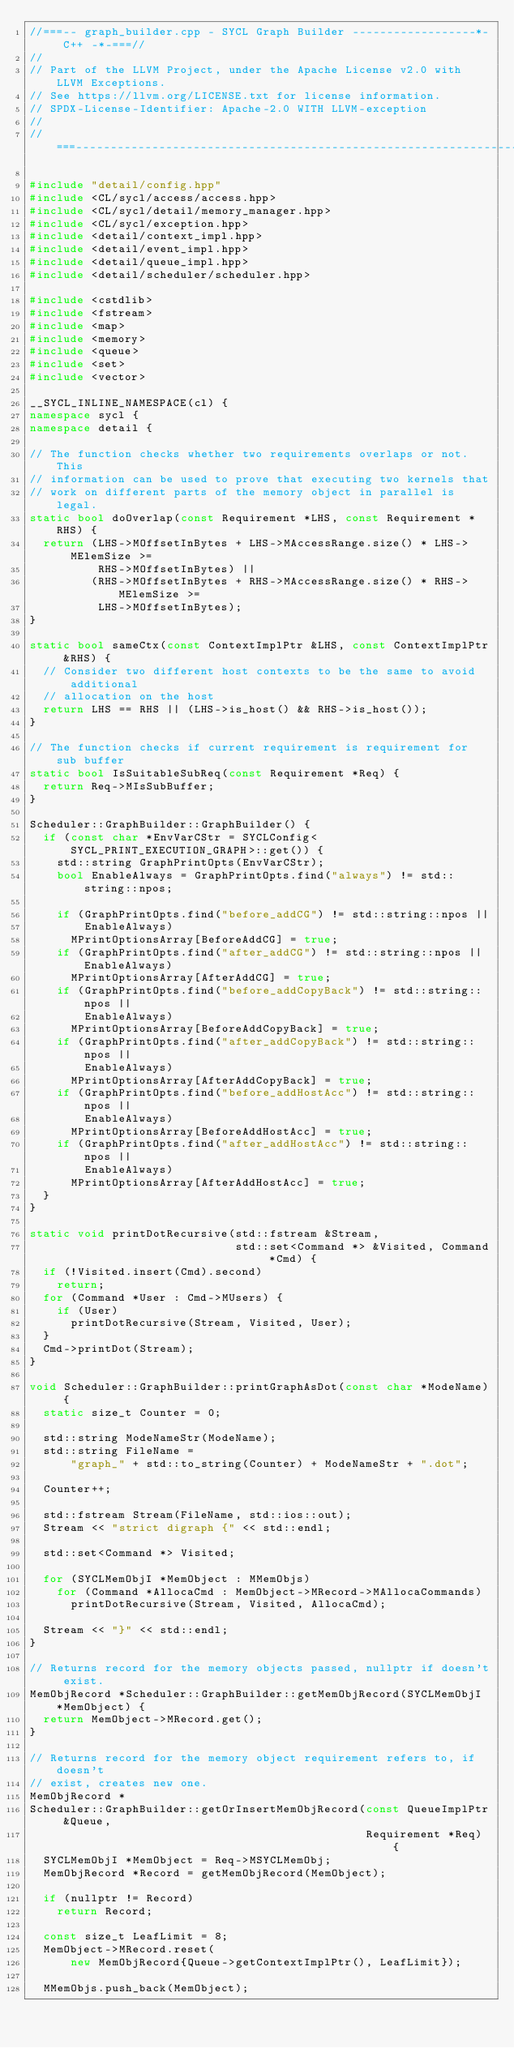<code> <loc_0><loc_0><loc_500><loc_500><_C++_>//===-- graph_builder.cpp - SYCL Graph Builder ------------------*- C++ -*-===//
//
// Part of the LLVM Project, under the Apache License v2.0 with LLVM Exceptions.
// See https://llvm.org/LICENSE.txt for license information.
// SPDX-License-Identifier: Apache-2.0 WITH LLVM-exception
//
//===----------------------------------------------------------------------===//

#include "detail/config.hpp"
#include <CL/sycl/access/access.hpp>
#include <CL/sycl/detail/memory_manager.hpp>
#include <CL/sycl/exception.hpp>
#include <detail/context_impl.hpp>
#include <detail/event_impl.hpp>
#include <detail/queue_impl.hpp>
#include <detail/scheduler/scheduler.hpp>

#include <cstdlib>
#include <fstream>
#include <map>
#include <memory>
#include <queue>
#include <set>
#include <vector>

__SYCL_INLINE_NAMESPACE(cl) {
namespace sycl {
namespace detail {

// The function checks whether two requirements overlaps or not. This
// information can be used to prove that executing two kernels that
// work on different parts of the memory object in parallel is legal.
static bool doOverlap(const Requirement *LHS, const Requirement *RHS) {
  return (LHS->MOffsetInBytes + LHS->MAccessRange.size() * LHS->MElemSize >=
          RHS->MOffsetInBytes) ||
         (RHS->MOffsetInBytes + RHS->MAccessRange.size() * RHS->MElemSize >=
          LHS->MOffsetInBytes);
}

static bool sameCtx(const ContextImplPtr &LHS, const ContextImplPtr &RHS) {
  // Consider two different host contexts to be the same to avoid additional
  // allocation on the host
  return LHS == RHS || (LHS->is_host() && RHS->is_host());
}

// The function checks if current requirement is requirement for sub buffer
static bool IsSuitableSubReq(const Requirement *Req) {
  return Req->MIsSubBuffer;
}

Scheduler::GraphBuilder::GraphBuilder() {
  if (const char *EnvVarCStr = SYCLConfig<SYCL_PRINT_EXECUTION_GRAPH>::get()) {
    std::string GraphPrintOpts(EnvVarCStr);
    bool EnableAlways = GraphPrintOpts.find("always") != std::string::npos;

    if (GraphPrintOpts.find("before_addCG") != std::string::npos ||
        EnableAlways)
      MPrintOptionsArray[BeforeAddCG] = true;
    if (GraphPrintOpts.find("after_addCG") != std::string::npos || EnableAlways)
      MPrintOptionsArray[AfterAddCG] = true;
    if (GraphPrintOpts.find("before_addCopyBack") != std::string::npos ||
        EnableAlways)
      MPrintOptionsArray[BeforeAddCopyBack] = true;
    if (GraphPrintOpts.find("after_addCopyBack") != std::string::npos ||
        EnableAlways)
      MPrintOptionsArray[AfterAddCopyBack] = true;
    if (GraphPrintOpts.find("before_addHostAcc") != std::string::npos ||
        EnableAlways)
      MPrintOptionsArray[BeforeAddHostAcc] = true;
    if (GraphPrintOpts.find("after_addHostAcc") != std::string::npos ||
        EnableAlways)
      MPrintOptionsArray[AfterAddHostAcc] = true;
  }
}

static void printDotRecursive(std::fstream &Stream,
                              std::set<Command *> &Visited, Command *Cmd) {
  if (!Visited.insert(Cmd).second)
    return;
  for (Command *User : Cmd->MUsers) {
    if (User)
      printDotRecursive(Stream, Visited, User);
  }
  Cmd->printDot(Stream);
}

void Scheduler::GraphBuilder::printGraphAsDot(const char *ModeName) {
  static size_t Counter = 0;

  std::string ModeNameStr(ModeName);
  std::string FileName =
      "graph_" + std::to_string(Counter) + ModeNameStr + ".dot";

  Counter++;

  std::fstream Stream(FileName, std::ios::out);
  Stream << "strict digraph {" << std::endl;

  std::set<Command *> Visited;

  for (SYCLMemObjI *MemObject : MMemObjs)
    for (Command *AllocaCmd : MemObject->MRecord->MAllocaCommands)
      printDotRecursive(Stream, Visited, AllocaCmd);

  Stream << "}" << std::endl;
}

// Returns record for the memory objects passed, nullptr if doesn't exist.
MemObjRecord *Scheduler::GraphBuilder::getMemObjRecord(SYCLMemObjI *MemObject) {
  return MemObject->MRecord.get();
}

// Returns record for the memory object requirement refers to, if doesn't
// exist, creates new one.
MemObjRecord *
Scheduler::GraphBuilder::getOrInsertMemObjRecord(const QueueImplPtr &Queue,
                                                 Requirement *Req) {
  SYCLMemObjI *MemObject = Req->MSYCLMemObj;
  MemObjRecord *Record = getMemObjRecord(MemObject);

  if (nullptr != Record)
    return Record;

  const size_t LeafLimit = 8;
  MemObject->MRecord.reset(
      new MemObjRecord{Queue->getContextImplPtr(), LeafLimit});

  MMemObjs.push_back(MemObject);</code> 